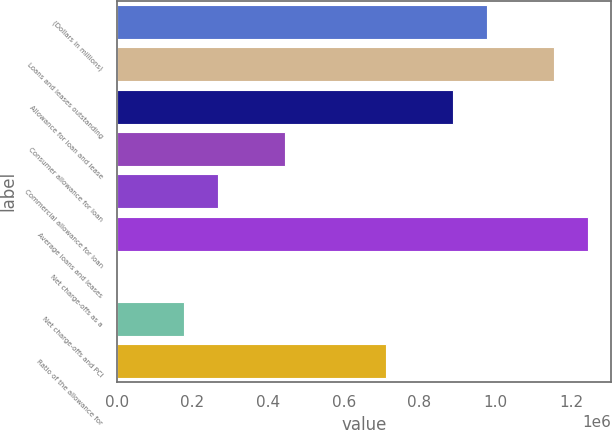<chart> <loc_0><loc_0><loc_500><loc_500><bar_chart><fcel>(Dollars in millions)<fcel>Loans and leases outstanding<fcel>Allowance for loan and lease<fcel>Consumer allowance for loan<fcel>Commercial allowance for loan<fcel>Average loans and leases<fcel>Net charge-offs as a<fcel>Net charge-offs and PCI<fcel>Ratio of the allowance for<nl><fcel>977684<fcel>1.15545e+06<fcel>888804<fcel>444402<fcel>266642<fcel>1.24433e+06<fcel>0.49<fcel>177761<fcel>711043<nl></chart> 